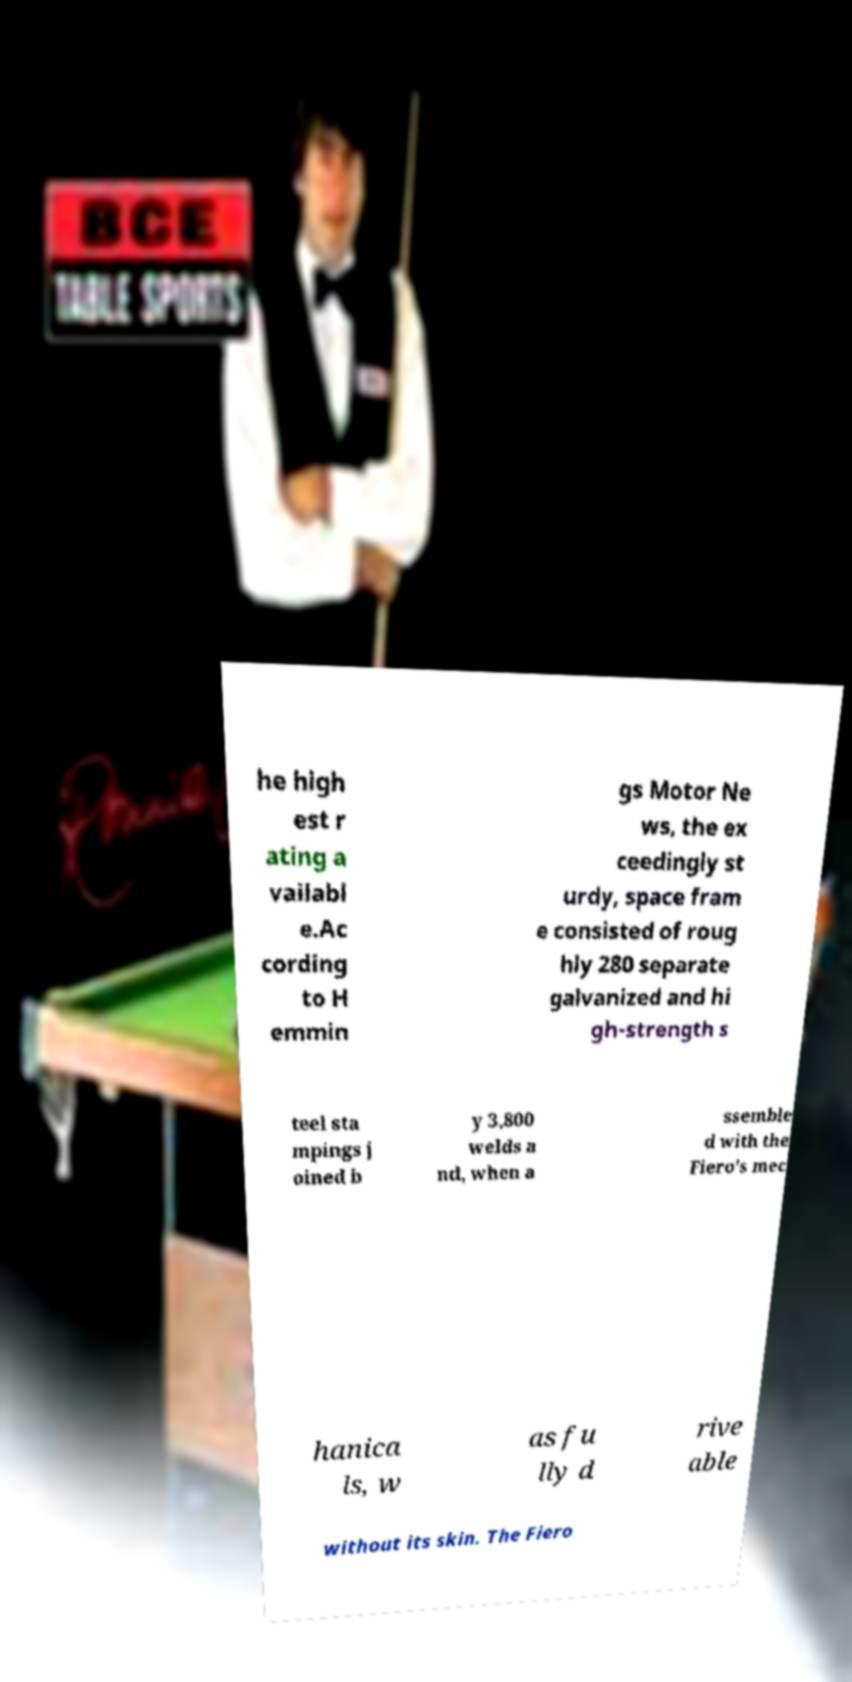What messages or text are displayed in this image? I need them in a readable, typed format. he high est r ating a vailabl e.Ac cording to H emmin gs Motor Ne ws, the ex ceedingly st urdy, space fram e consisted of roug hly 280 separate galvanized and hi gh-strength s teel sta mpings j oined b y 3,800 welds a nd, when a ssemble d with the Fiero's mec hanica ls, w as fu lly d rive able without its skin. The Fiero 